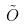Convert formula to latex. <formula><loc_0><loc_0><loc_500><loc_500>\tilde { O }</formula> 